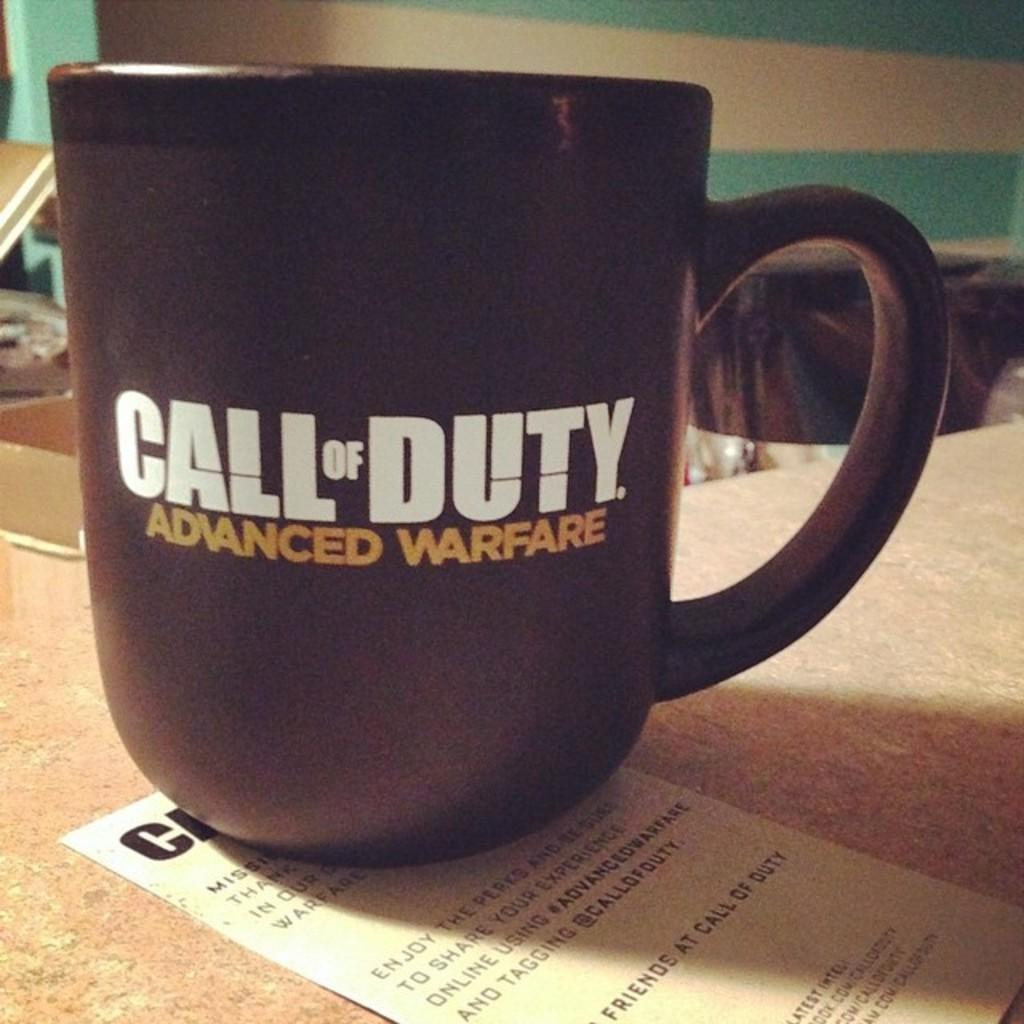<image>
Describe the image concisely. A black Call of Duty Advanced Warfare mug sits on top of a piece of paper 